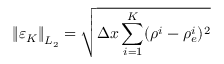<formula> <loc_0><loc_0><loc_500><loc_500>\left \| \varepsilon _ { K } \right \| _ { L _ { 2 } } = \sqrt { \Delta x \sum _ { i = 1 } ^ { K } ( \rho ^ { i } - \rho _ { e } ^ { i } ) ^ { 2 } }</formula> 